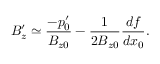<formula> <loc_0><loc_0><loc_500><loc_500>B _ { z } ^ { \prime } \simeq \frac { - p _ { 0 } ^ { \prime } } { B _ { z 0 } } - \frac { 1 } { 2 B _ { z 0 } } \frac { d f } { d x _ { 0 } } .</formula> 